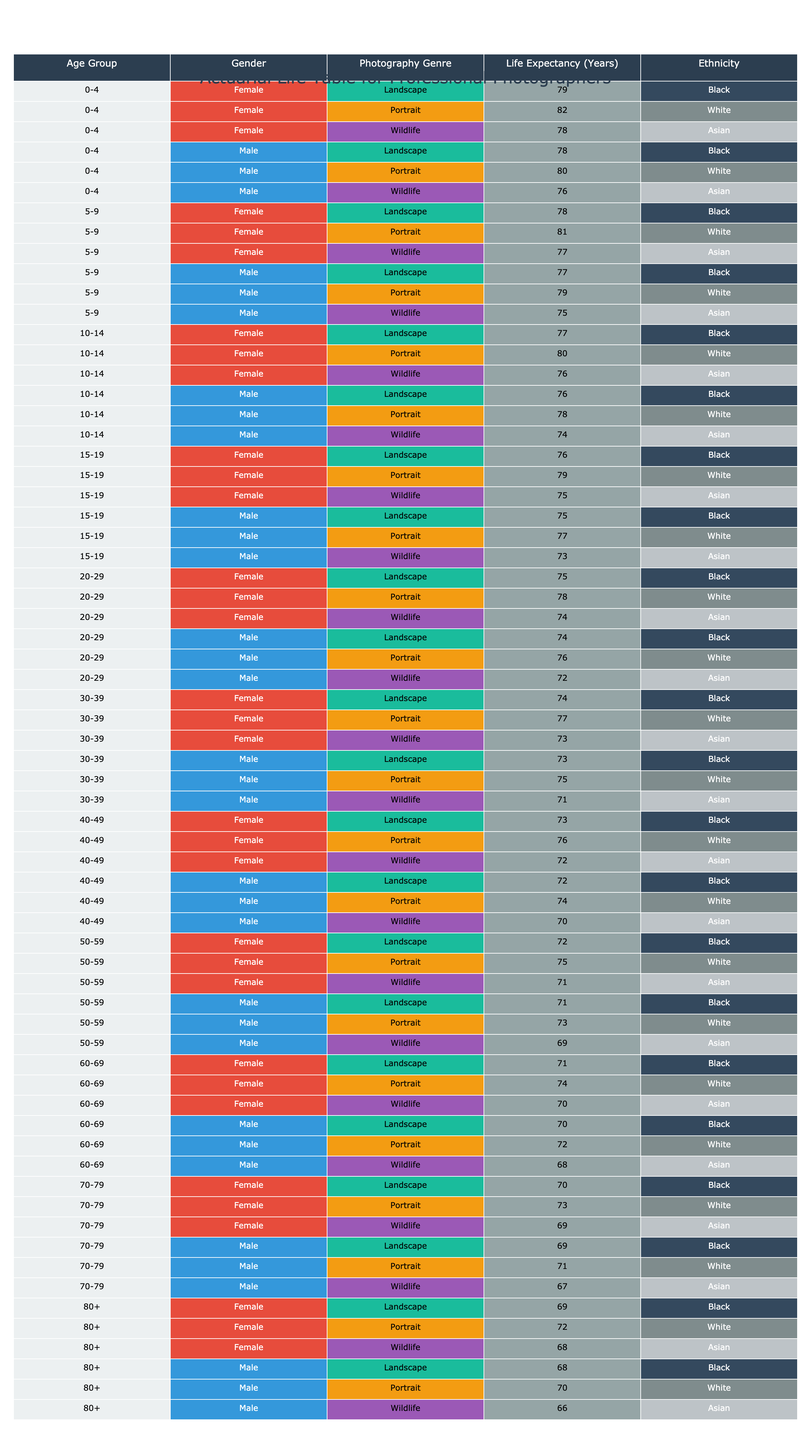What is the life expectancy of a 0-4-year-old female wildlife photographer? Looking at the table, we check the age group '0-4', gender 'Female', and photography genre 'Wildlife'. The life expectancy value for this combination is 78 years.
Answer: 78 Which age group has the highest life expectancy for male photographers? To find this, we look through the life expectancy column for all male entries, identifying the highest value. The maximum life expectancy for males is 80 years in the '0-4' age group.
Answer: 80 Is the life expectancy for Asian female wildlife photographers higher or lower than that for Black male landscape photographers? Reviewing the table, the life expectancy for Asian female wildlife photographers is 70 years, while for Black male landscape photographers it is 72 years. Therefore, the answer is lower for Asians.
Answer: Lower What is the average life expectancy of female portrait photographers aged 50-59? Checking the entries for female portrait photographers aged 50-59, we have two values: 75 years and 73 years. The sum of these values is 75 + 73 = 148, and there are 2 entries. Therefore, the average is 148 / 2 = 74 years.
Answer: 74 What is the difference in life expectancy between Black female landscape photographers and White female wildlife photographers aged 40-49? First, we find the life expectancy for Black female landscape photographers, which is 73 years, and for White female wildlife photographers, which is 72 years. To find the difference: 73 - 72 = 1 year. So, Black females have a higher life expectancy by 1 year.
Answer: 1 year 